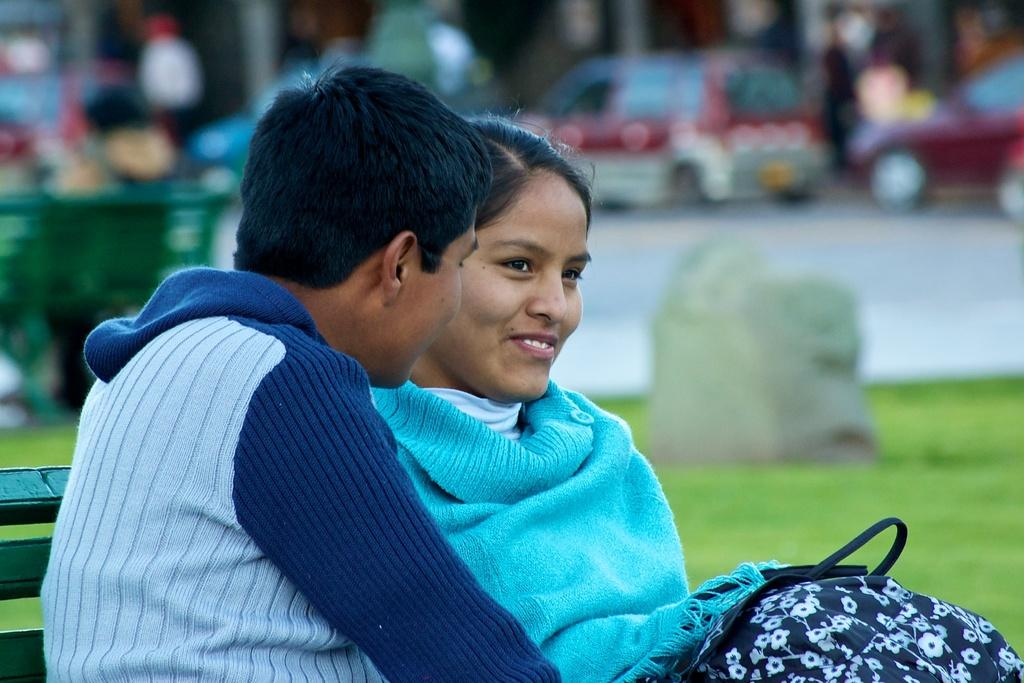Who are the people in the image? There is a man and a woman in the image. What are the man and woman doing in the image? Both the man and woman are sitting on a bench. Can you describe the background of the image? The background of the image is blurred. What type of education can be seen in the image? There is no reference to education in the image; it features a man and a woman sitting on a bench. How many mittens are visible in the image? There are no mittens present in the image. 